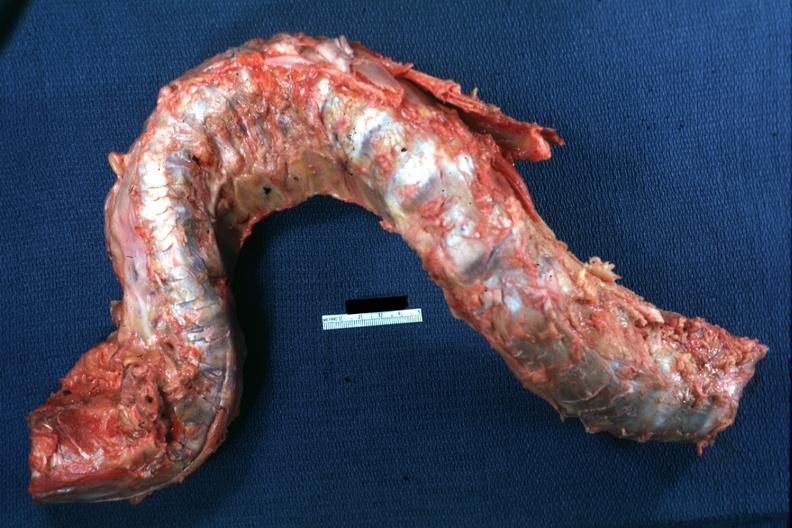s hypersegmented neutrophil deformed?
Answer the question using a single word or phrase. No 